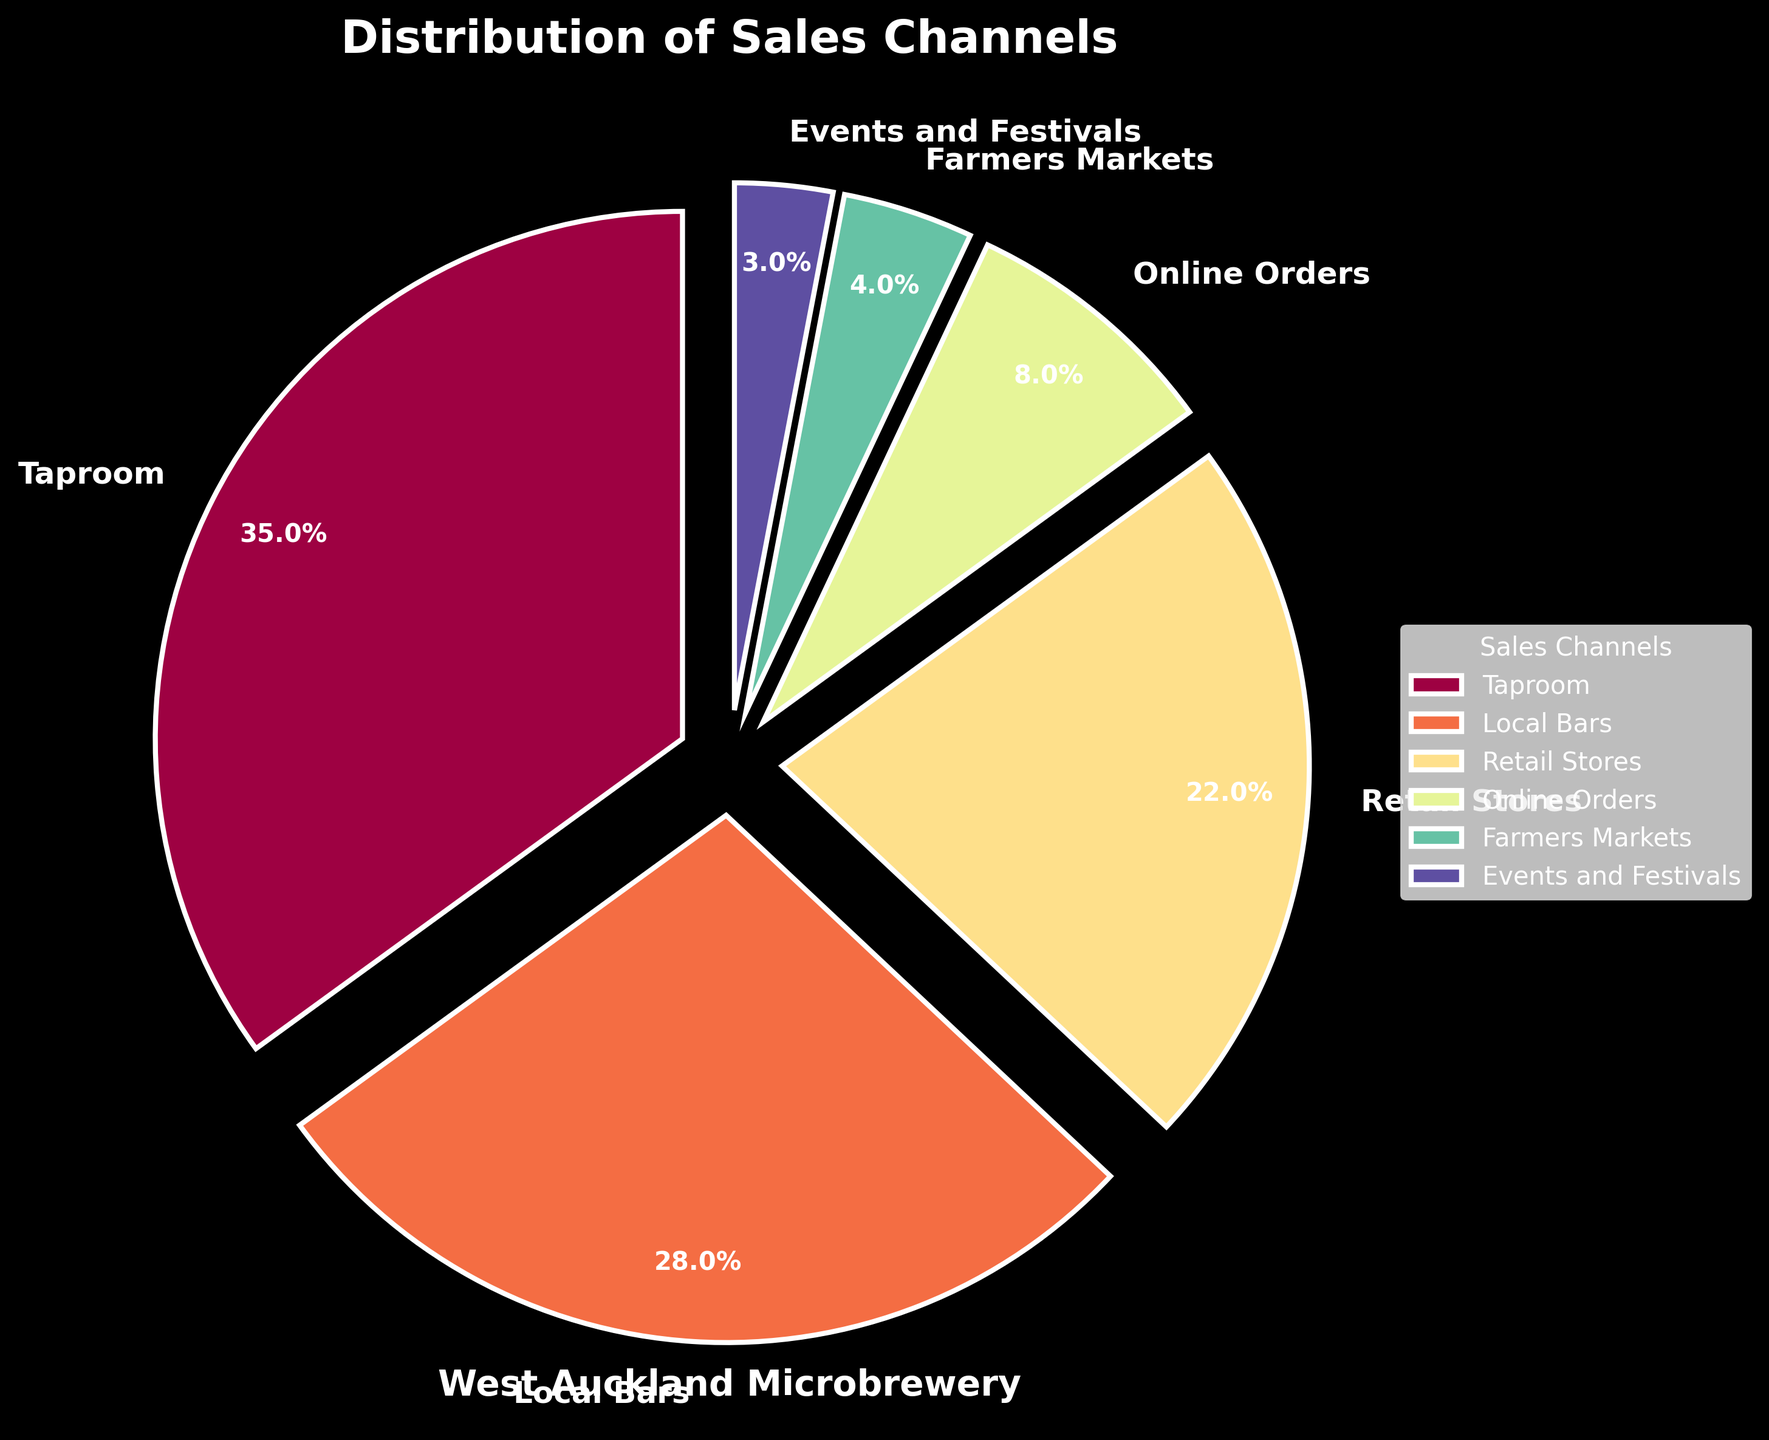Which sales channel has the highest percentage? The pie chart shows the percentage distribution of different sales channels, and the Taproom segment has the largest portion of the pie.
Answer: Taproom How many more percentage points does Taproom have compared to Local Bars? From the pie chart, the percentage for Taproom is 35%, and for Local Bars, it is 28%. The difference between them is 35% - 28%.
Answer: 7% What is the combined percentage of Retail Stores and Online Orders? To find the combined percentage, add the percentages of Retail Stores (22%) and Online Orders (8%).
Answer: 30% Which sales channels collectively make up less than 10% of the sales? The pie chart shows Farmers Markets (4%), and Events and Festivals (3%). Adding them gives 4% + 3%, which is less than 10%.
Answer: Farmers Markets, Events and Festivals Which segment has the smallest portion of the pie chart? Observing the pie chart, the smallest portion corresponds to Events and Festivals.
Answer: Events and Festivals Is the sum of the percentage of Taproom, Local Bars, and Retail Stores greater than 75%? Add the percentages of Taproom (35%), Local Bars (28%), and Retail Stores (22%) to get 35% + 28% + 22%. The result is 85%, which is more than 75%.
Answer: Yes Which sales channels have percentages above the average percentage of all channels? First, calculate the average percentage: (35 + 28 + 22 + 8 + 4 + 3) / 6 = 16.67%. The channels with percentages above this are Taproom (35%), Local Bars (28%), and Retail Stores (22%).
Answer: Taproom, Local Bars, Retail Stores How much more percentage does Online Orders have compared to Farmers Markets? Calculate the difference in percentages: Online Orders (8%) - Farmers Markets (4%) = 4%.
Answer: 4% What is the combined percentage of the least three contributing sales channels? Add the percentages of Events and Festivals (3%), Farmers Markets (4%), and Online Orders (8%), yielding 3% + 4% + 8%.
Answer: 15% Which segments together form a quarter of the total sales? Look at the segments and find a combination whose percentages add up to 25%. Local Bars (28%) is close, and combining Retail Stores (22%) and Farmers Markets (4%) adds up exactly to 22% + 4% = 26%, which is slightly over 25%. Events and Festivals (3%) and Online Orders (8%) add up to lesser than 25%. Only Local Bars (28%) can be a close approximation.
Answer: Local Bars, Retail Stores, Farmers Markets 